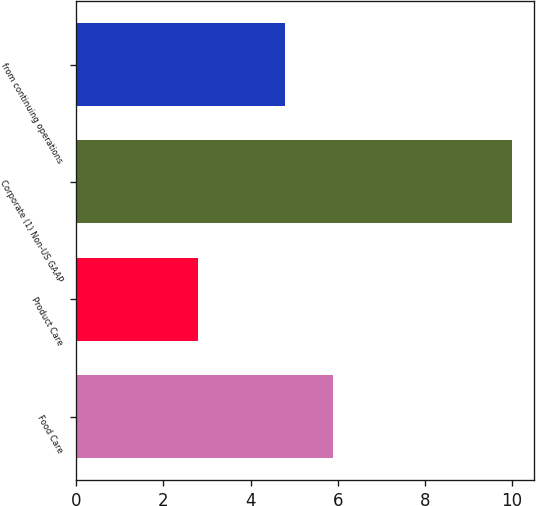<chart> <loc_0><loc_0><loc_500><loc_500><bar_chart><fcel>Food Care<fcel>Product Care<fcel>Corporate (1) Non-US GAAP<fcel>from continuing operations<nl><fcel>5.9<fcel>2.8<fcel>10<fcel>4.8<nl></chart> 